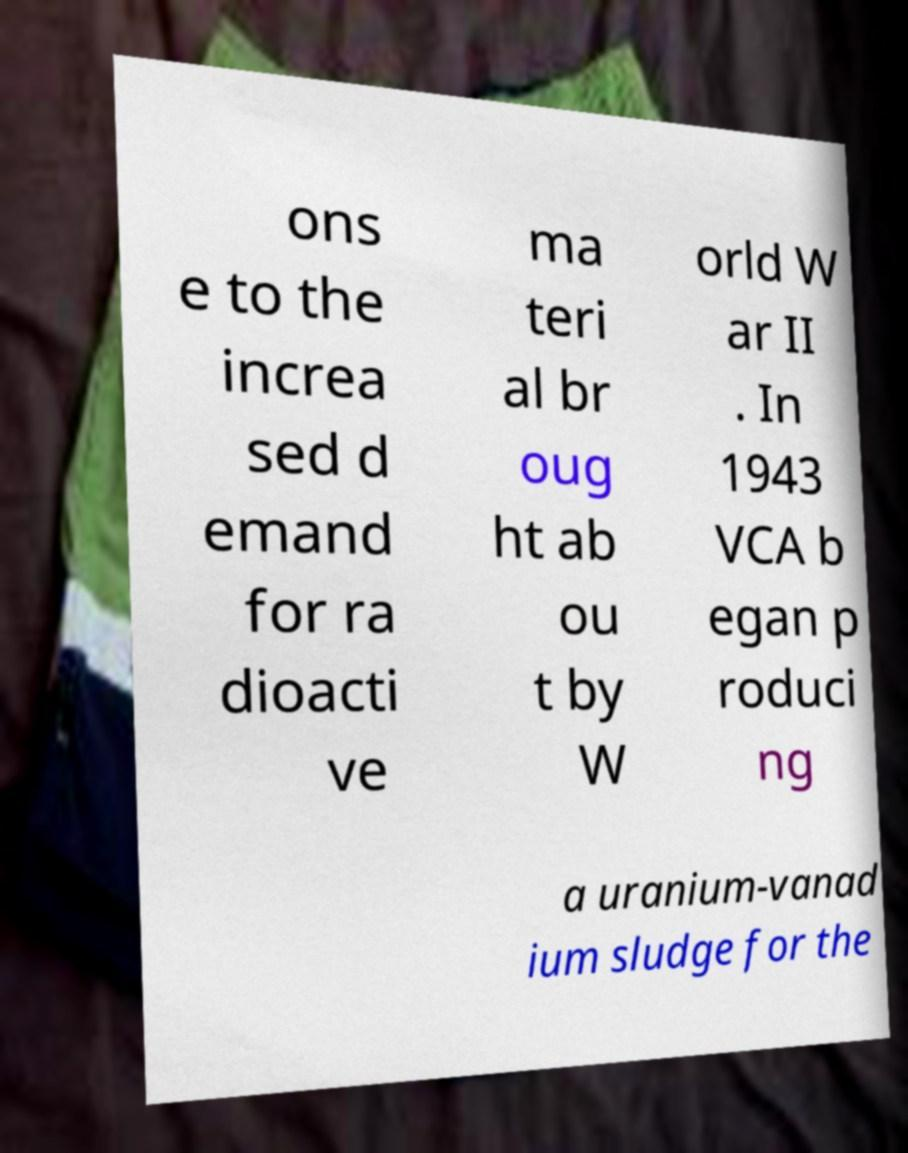Can you read and provide the text displayed in the image?This photo seems to have some interesting text. Can you extract and type it out for me? ons e to the increa sed d emand for ra dioacti ve ma teri al br oug ht ab ou t by W orld W ar II . In 1943 VCA b egan p roduci ng a uranium-vanad ium sludge for the 